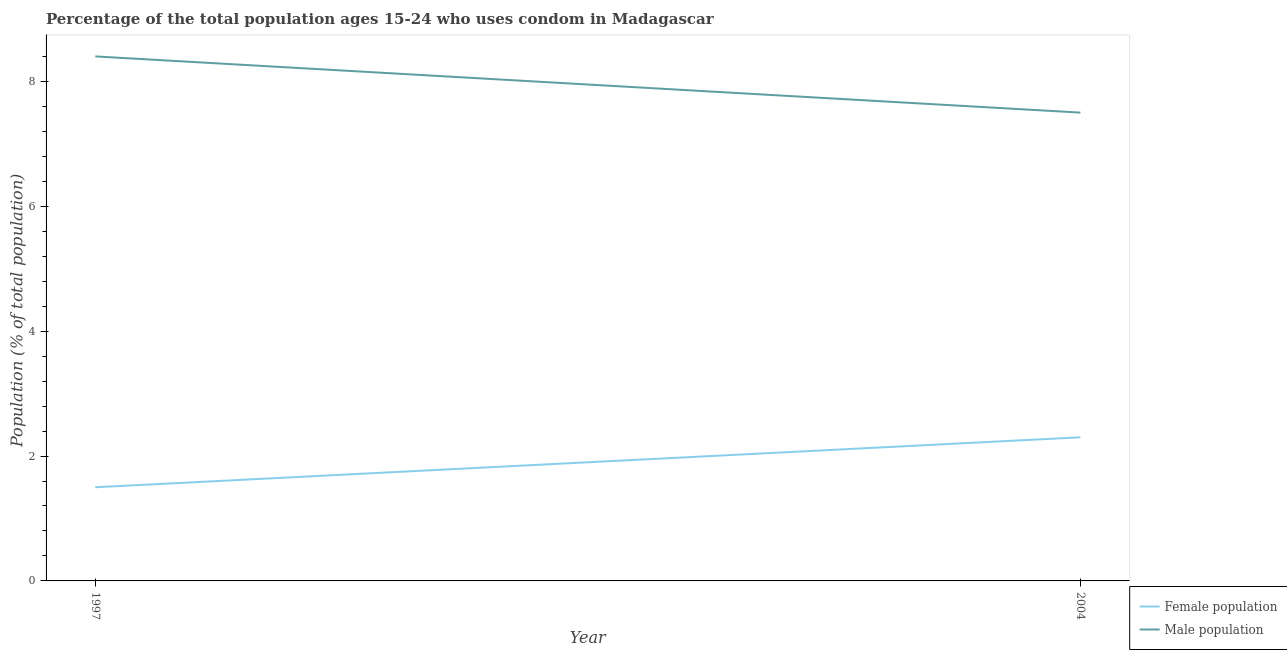Is the number of lines equal to the number of legend labels?
Your answer should be compact. Yes. What is the male population in 2004?
Keep it short and to the point. 7.5. In which year was the female population maximum?
Ensure brevity in your answer.  2004. What is the total male population in the graph?
Offer a terse response. 15.9. What is the difference between the male population in 1997 and that in 2004?
Your answer should be compact. 0.9. What is the difference between the female population in 2004 and the male population in 1997?
Give a very brief answer. -6.1. What is the average male population per year?
Offer a very short reply. 7.95. In the year 2004, what is the difference between the female population and male population?
Give a very brief answer. -5.2. In how many years, is the male population greater than 7.6 %?
Give a very brief answer. 1. What is the ratio of the male population in 1997 to that in 2004?
Provide a short and direct response. 1.12. Is the female population in 1997 less than that in 2004?
Offer a very short reply. Yes. In how many years, is the male population greater than the average male population taken over all years?
Make the answer very short. 1. Is the female population strictly less than the male population over the years?
Provide a succinct answer. Yes. How many lines are there?
Offer a very short reply. 2. Does the graph contain any zero values?
Give a very brief answer. No. Does the graph contain grids?
Make the answer very short. No. Where does the legend appear in the graph?
Your answer should be compact. Bottom right. What is the title of the graph?
Offer a very short reply. Percentage of the total population ages 15-24 who uses condom in Madagascar. What is the label or title of the X-axis?
Give a very brief answer. Year. What is the label or title of the Y-axis?
Offer a terse response. Population (% of total population) . What is the Population (% of total population)  of Female population in 1997?
Give a very brief answer. 1.5. What is the Population (% of total population)  in Male population in 1997?
Your answer should be compact. 8.4. What is the Population (% of total population)  in Female population in 2004?
Keep it short and to the point. 2.3. Across all years, what is the minimum Population (% of total population)  in Male population?
Make the answer very short. 7.5. What is the total Population (% of total population)  of Male population in the graph?
Your response must be concise. 15.9. What is the difference between the Population (% of total population)  of Female population in 1997 and that in 2004?
Offer a very short reply. -0.8. What is the difference between the Population (% of total population)  of Male population in 1997 and that in 2004?
Offer a terse response. 0.9. What is the difference between the Population (% of total population)  of Female population in 1997 and the Population (% of total population)  of Male population in 2004?
Your answer should be very brief. -6. What is the average Population (% of total population)  of Male population per year?
Your answer should be very brief. 7.95. In the year 1997, what is the difference between the Population (% of total population)  of Female population and Population (% of total population)  of Male population?
Make the answer very short. -6.9. What is the ratio of the Population (% of total population)  of Female population in 1997 to that in 2004?
Provide a succinct answer. 0.65. What is the ratio of the Population (% of total population)  in Male population in 1997 to that in 2004?
Offer a terse response. 1.12. What is the difference between the highest and the second highest Population (% of total population)  in Female population?
Offer a terse response. 0.8. What is the difference between the highest and the lowest Population (% of total population)  in Male population?
Offer a very short reply. 0.9. 